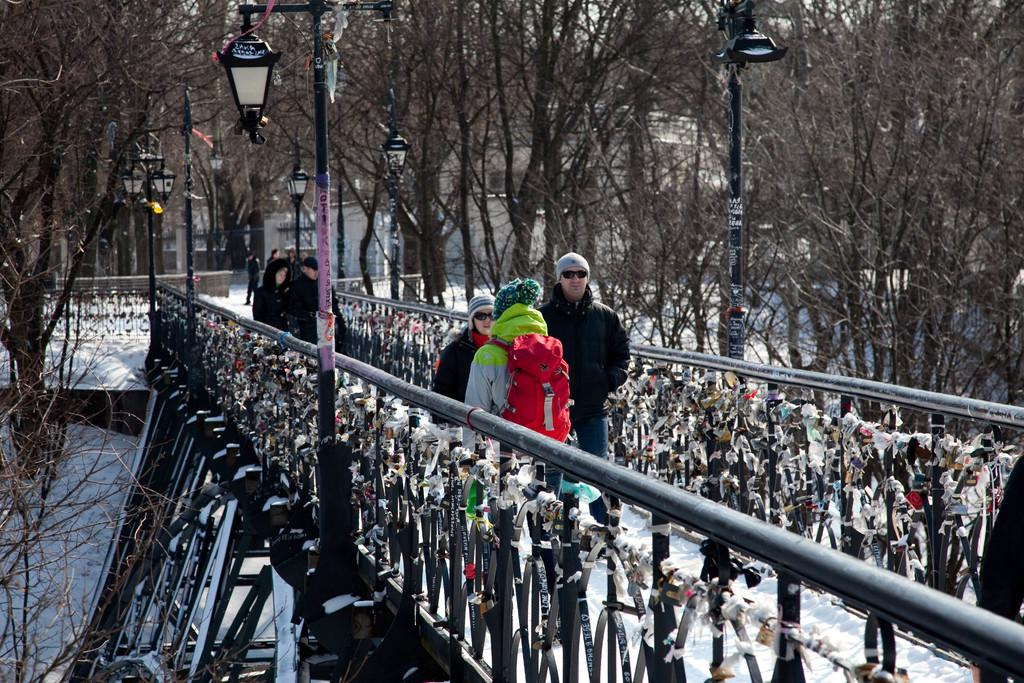Who or what can be seen in the image? There are people in the image. What is the condition of the bridge in the image? The bridge is covered with snow in the image. What type of lighting is present in the image? There are pole lights in the image. What can be seen in the background of the image? There are trees and a building in the background of the image. Can you hear the horn of a vehicle in the image? There is no mention of a vehicle or a horn in the image, so it cannot be heard. 